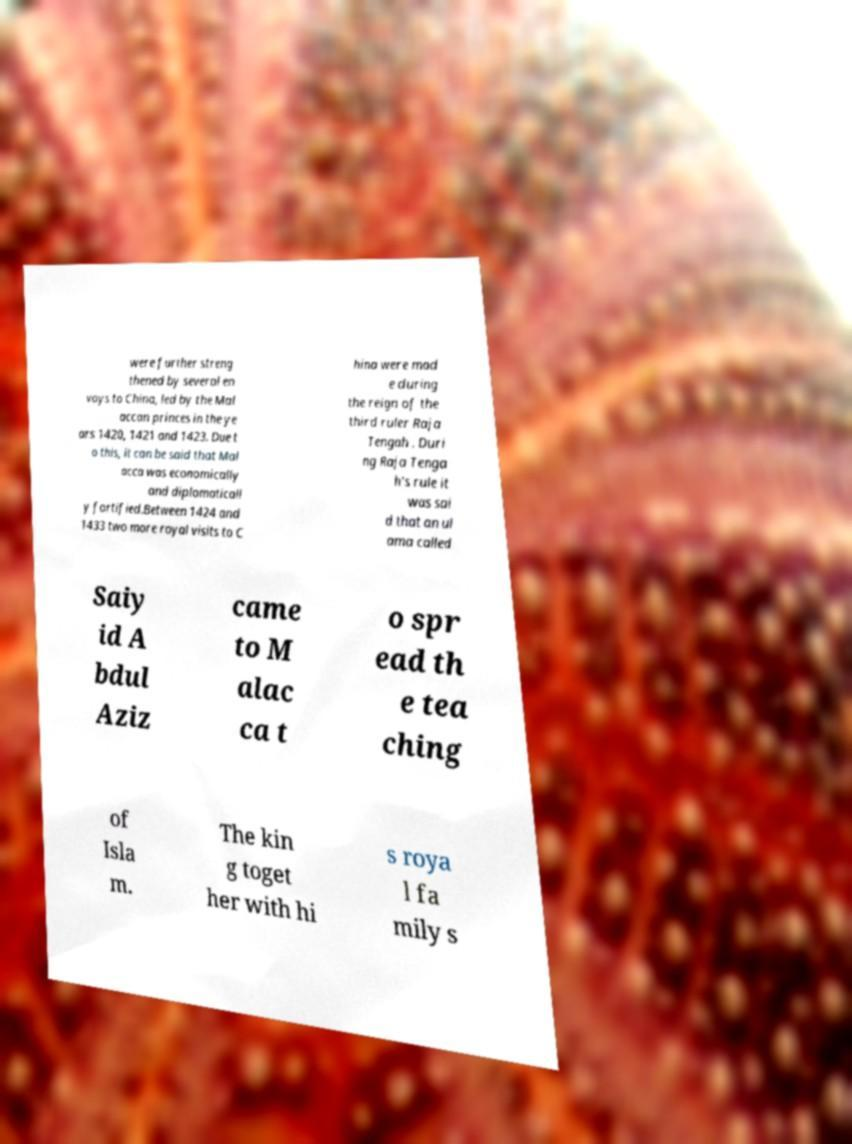What messages or text are displayed in this image? I need them in a readable, typed format. were further streng thened by several en voys to China, led by the Mal accan princes in the ye ars 1420, 1421 and 1423. Due t o this, it can be said that Mal acca was economically and diplomaticall y fortified.Between 1424 and 1433 two more royal visits to C hina were mad e during the reign of the third ruler Raja Tengah . Duri ng Raja Tenga h's rule it was sai d that an ul ama called Saiy id A bdul Aziz came to M alac ca t o spr ead th e tea ching of Isla m. The kin g toget her with hi s roya l fa mily s 